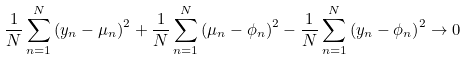Convert formula to latex. <formula><loc_0><loc_0><loc_500><loc_500>\frac { 1 } { N } \sum _ { n = 1 } ^ { N } \left ( y _ { n } - \mu _ { n } \right ) ^ { 2 } + \frac { 1 } { N } \sum _ { n = 1 } ^ { N } \left ( \mu _ { n } - \phi _ { n } \right ) ^ { 2 } - \frac { 1 } { N } \sum _ { n = 1 } ^ { N } \left ( y _ { n } - \phi _ { n } \right ) ^ { 2 } \to 0</formula> 